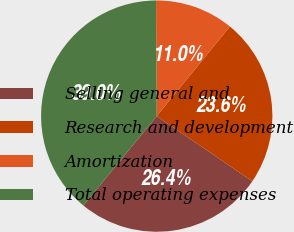Convert chart to OTSL. <chart><loc_0><loc_0><loc_500><loc_500><pie_chart><fcel>Selling general and<fcel>Research and development<fcel>Amortization<fcel>Total operating expenses<nl><fcel>26.42%<fcel>23.62%<fcel>10.99%<fcel>38.97%<nl></chart> 